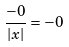Convert formula to latex. <formula><loc_0><loc_0><loc_500><loc_500>\frac { - 0 } { | x | } = - 0</formula> 